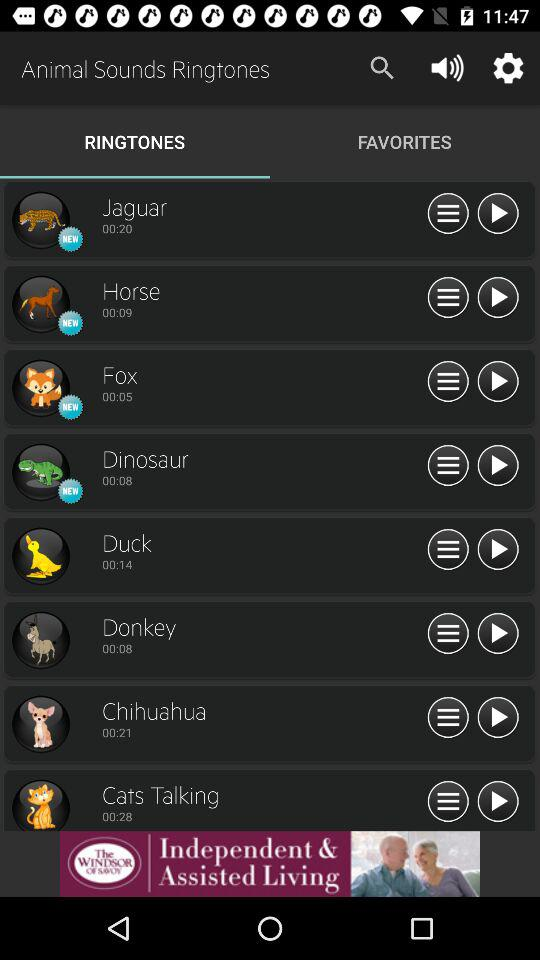Is "Fox" a new ringtone? "Fox" is a new ringtone. 